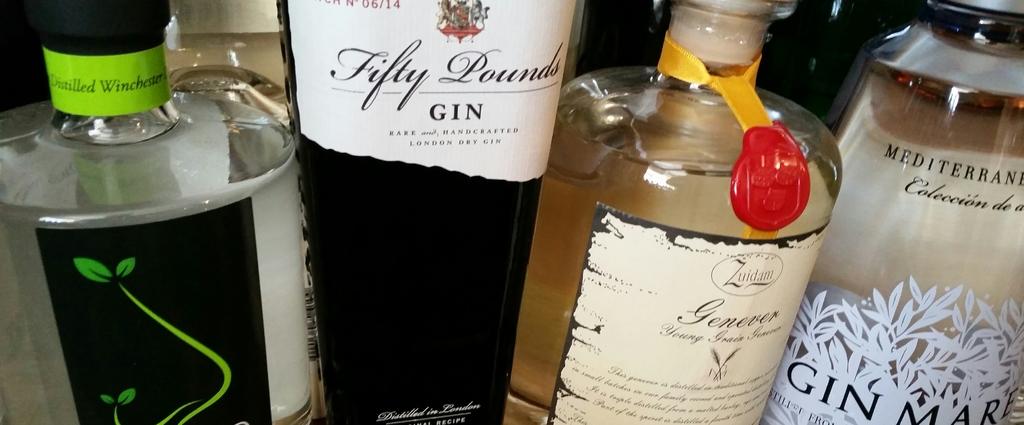What is the brand of gin?
Provide a succinct answer. Fifty pounds. What type of alcohol?
Your answer should be compact. Gin. 